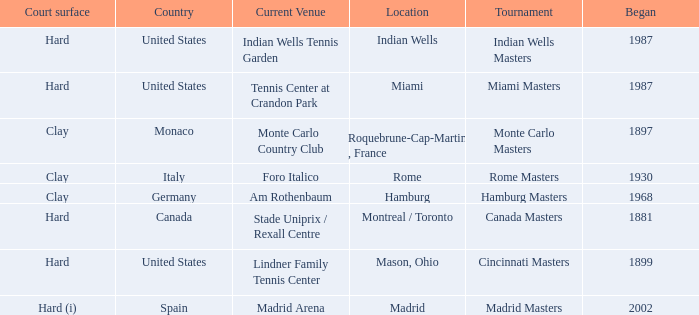Which tournaments current venue is the Madrid Arena? Madrid Masters. 